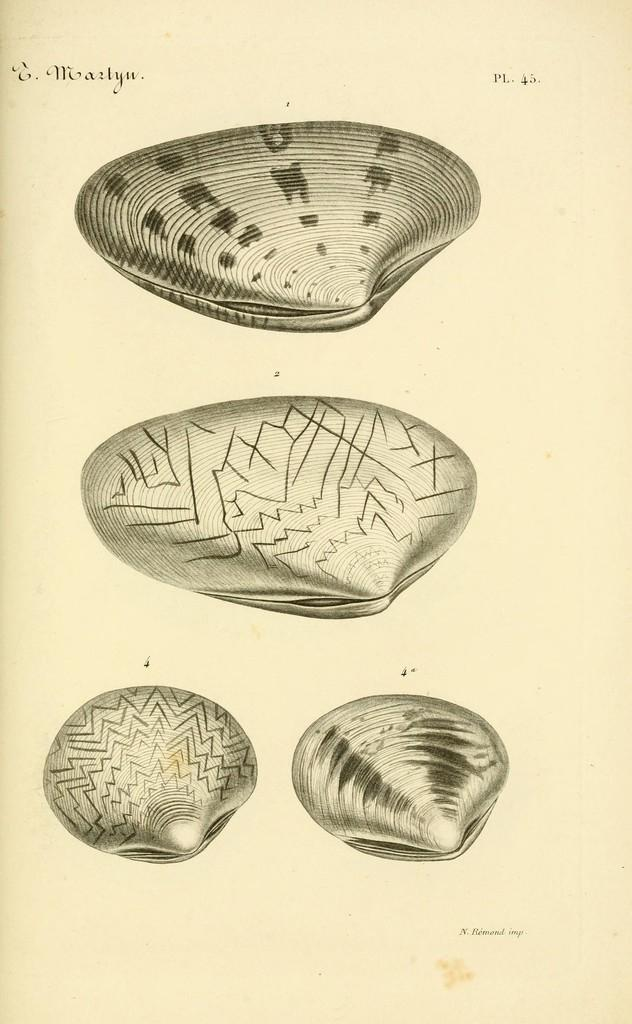What types of objects can be seen in the image? There are different shells in the image. Can you describe the shells in the image? The shells in the image have various shapes and sizes. What might be the origin of these shells? The shells in the image could be from the ocean or a body of water. How many cherries are on the car in the image? There are no cherries or cars present in the image; it only contains different shells. 